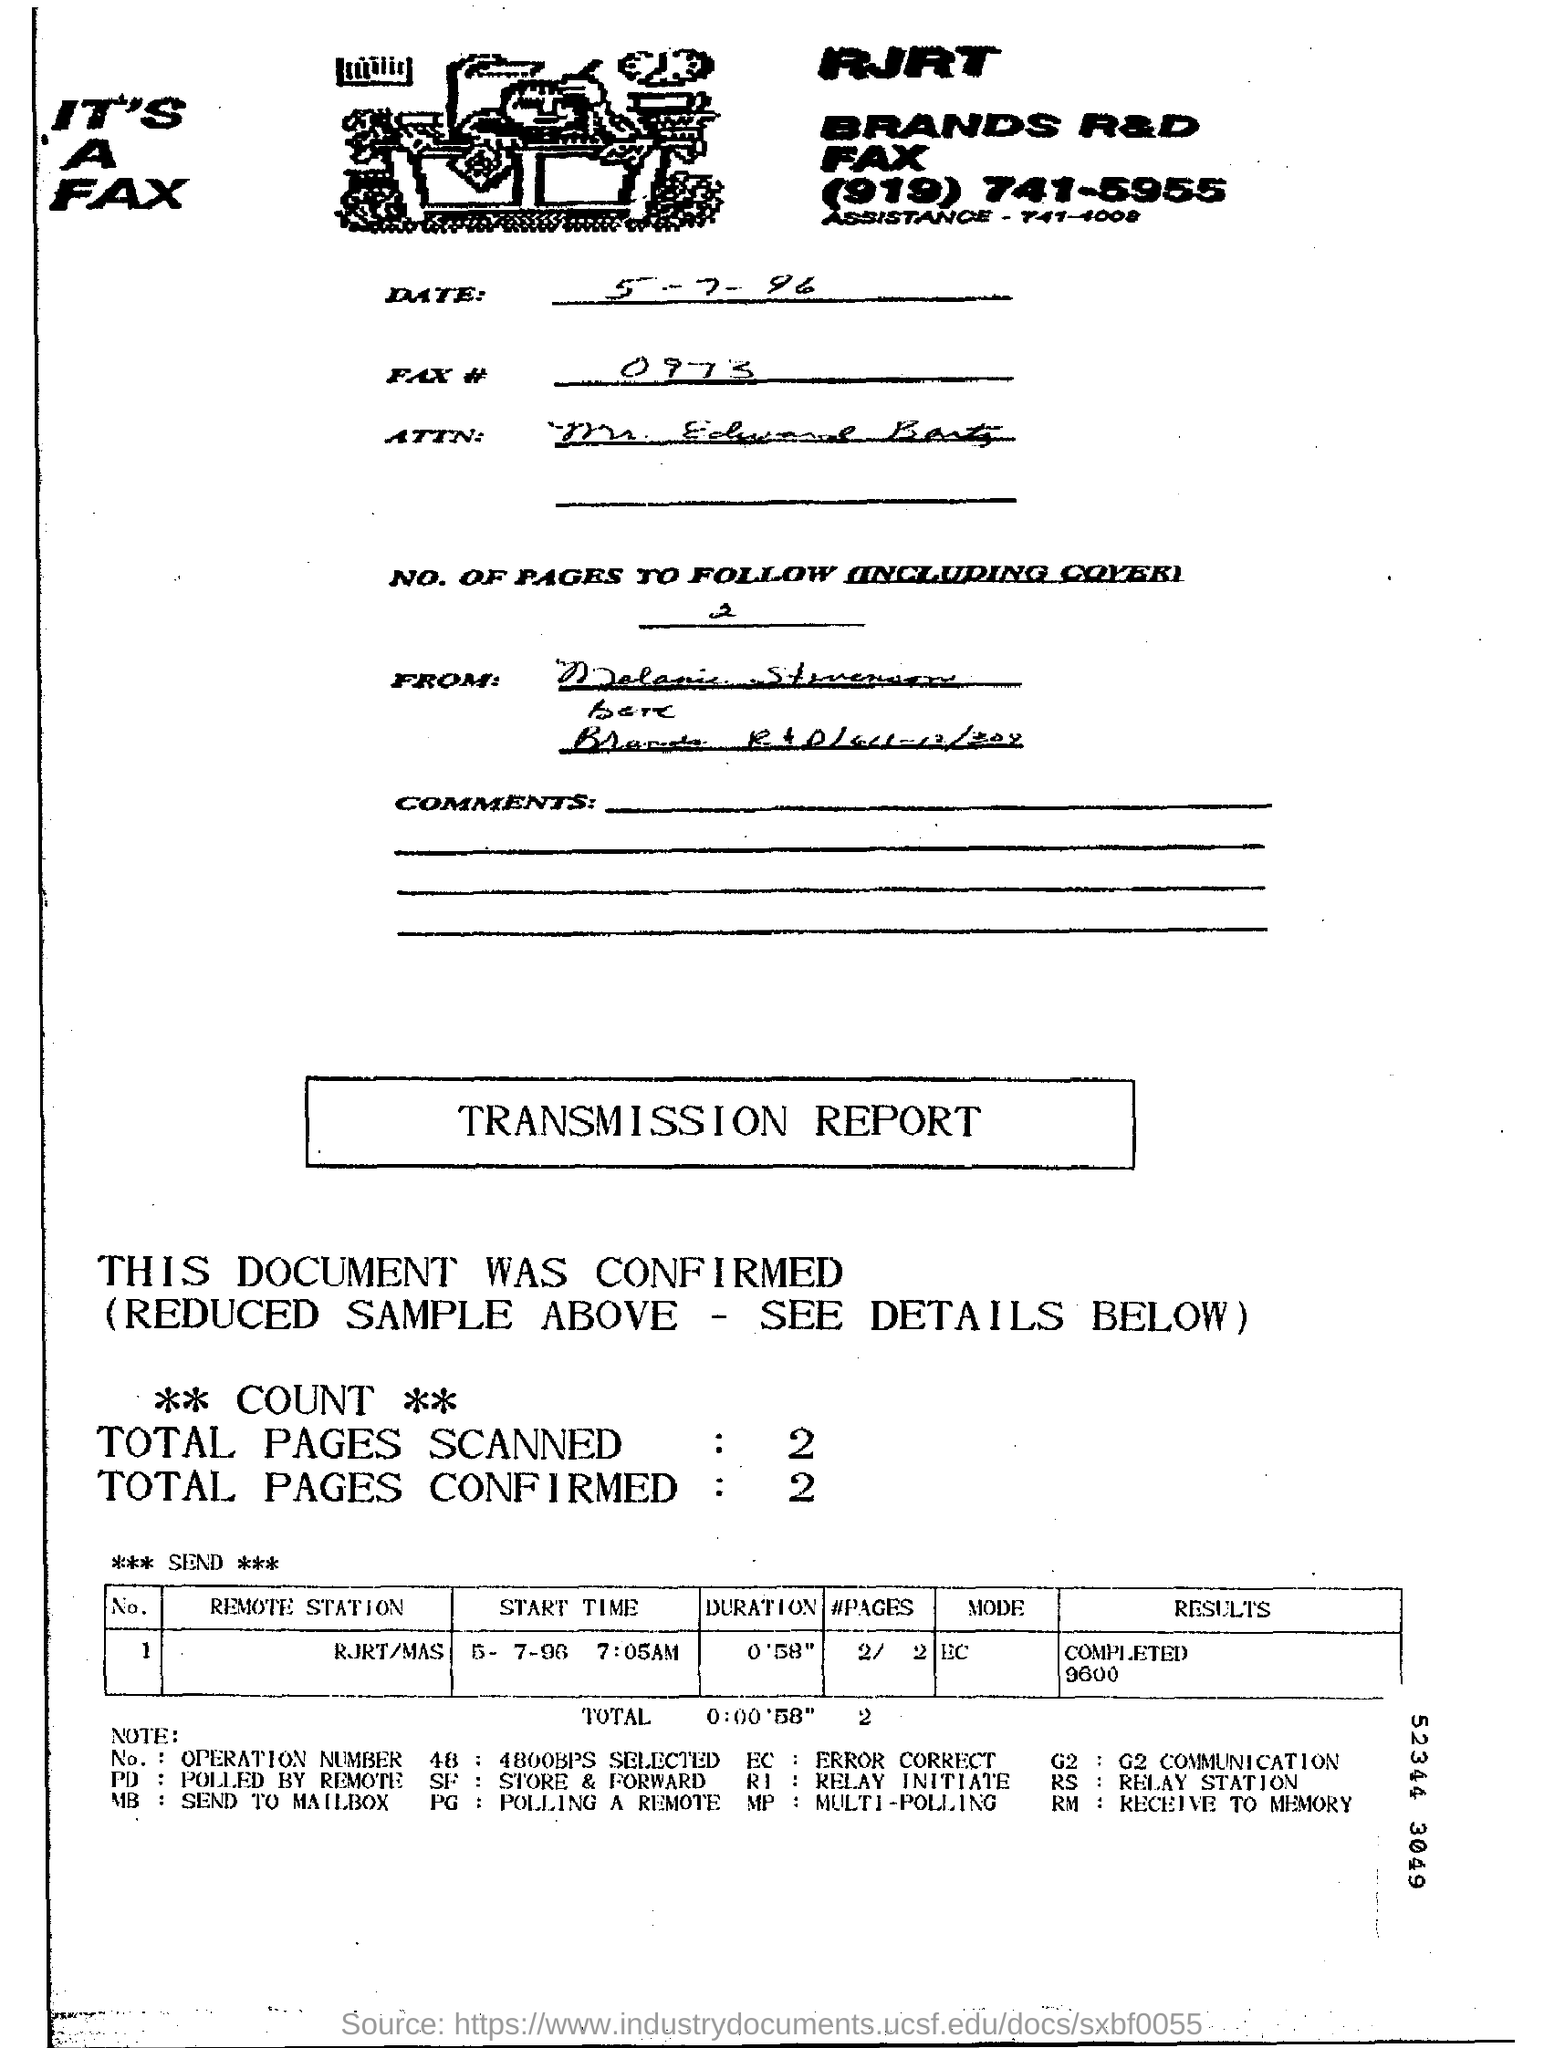Draw attention to some important aspects in this diagram. The total number of confirmed pages is 2. In total, 2 pages were scanned. 